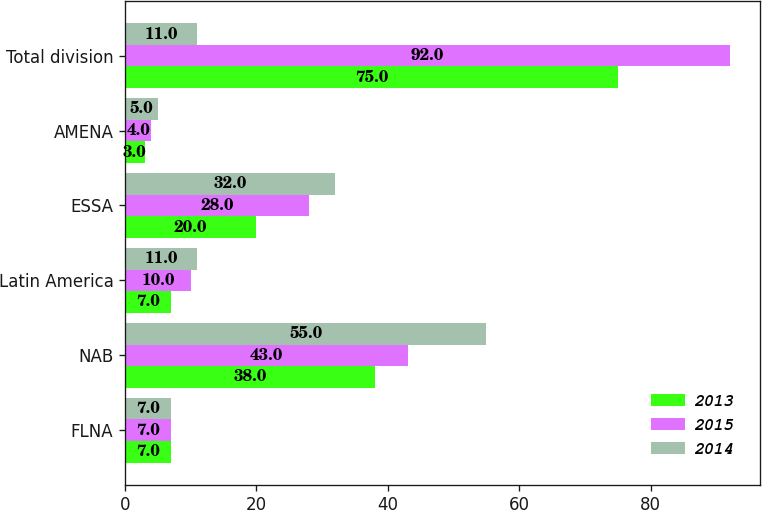<chart> <loc_0><loc_0><loc_500><loc_500><stacked_bar_chart><ecel><fcel>FLNA<fcel>NAB<fcel>Latin America<fcel>ESSA<fcel>AMENA<fcel>Total division<nl><fcel>2013<fcel>7<fcel>38<fcel>7<fcel>20<fcel>3<fcel>75<nl><fcel>2015<fcel>7<fcel>43<fcel>10<fcel>28<fcel>4<fcel>92<nl><fcel>2014<fcel>7<fcel>55<fcel>11<fcel>32<fcel>5<fcel>11<nl></chart> 